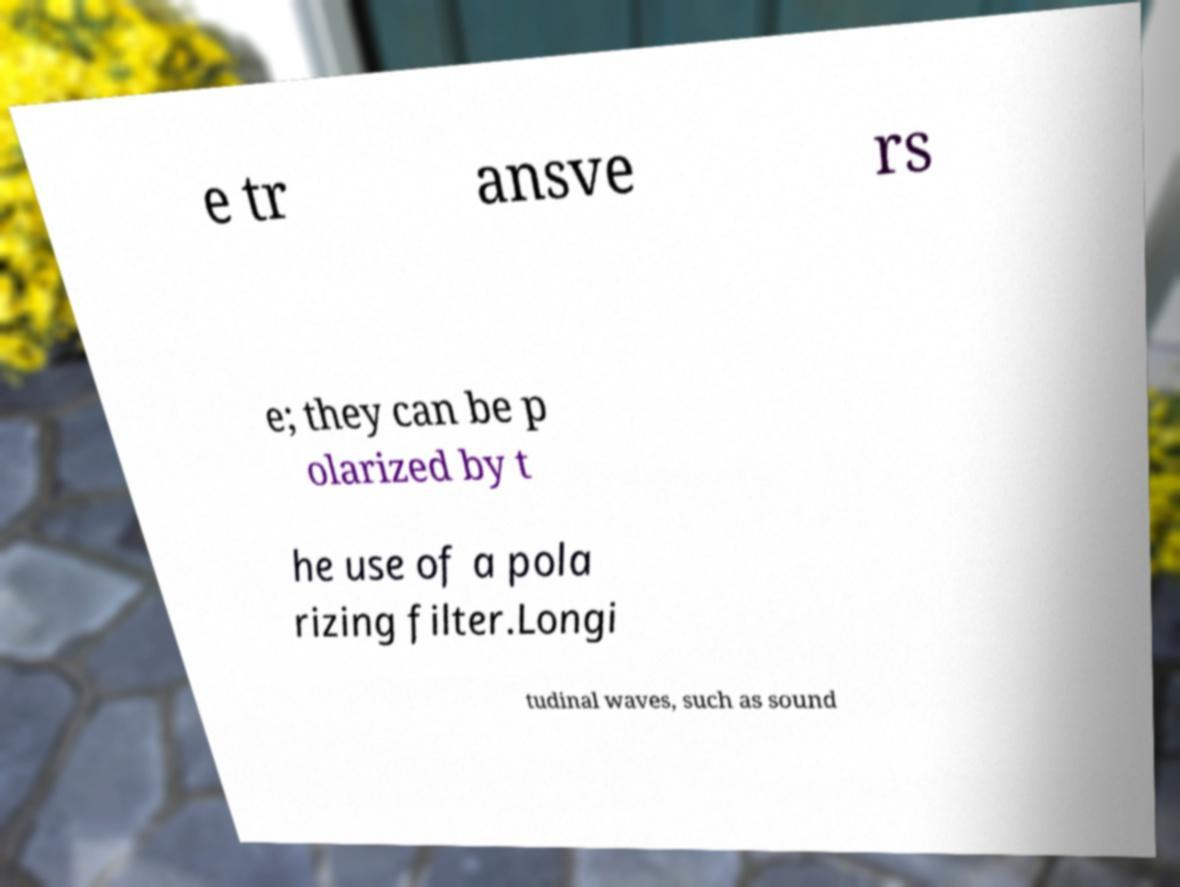For documentation purposes, I need the text within this image transcribed. Could you provide that? e tr ansve rs e; they can be p olarized by t he use of a pola rizing filter.Longi tudinal waves, such as sound 